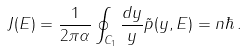Convert formula to latex. <formula><loc_0><loc_0><loc_500><loc_500>J ( E ) = \frac { 1 } { 2 \pi \alpha } \oint _ { C _ { 1 } } \frac { d y } { y } \tilde { p } ( y , E ) = n \hbar { \, } .</formula> 